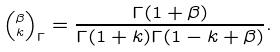<formula> <loc_0><loc_0><loc_500><loc_500>\left ( ^ { \beta } _ { k } \right ) _ { \Gamma } = \frac { \Gamma ( 1 + \beta ) } { \Gamma ( 1 + k ) \Gamma ( 1 - k + \beta ) } .</formula> 